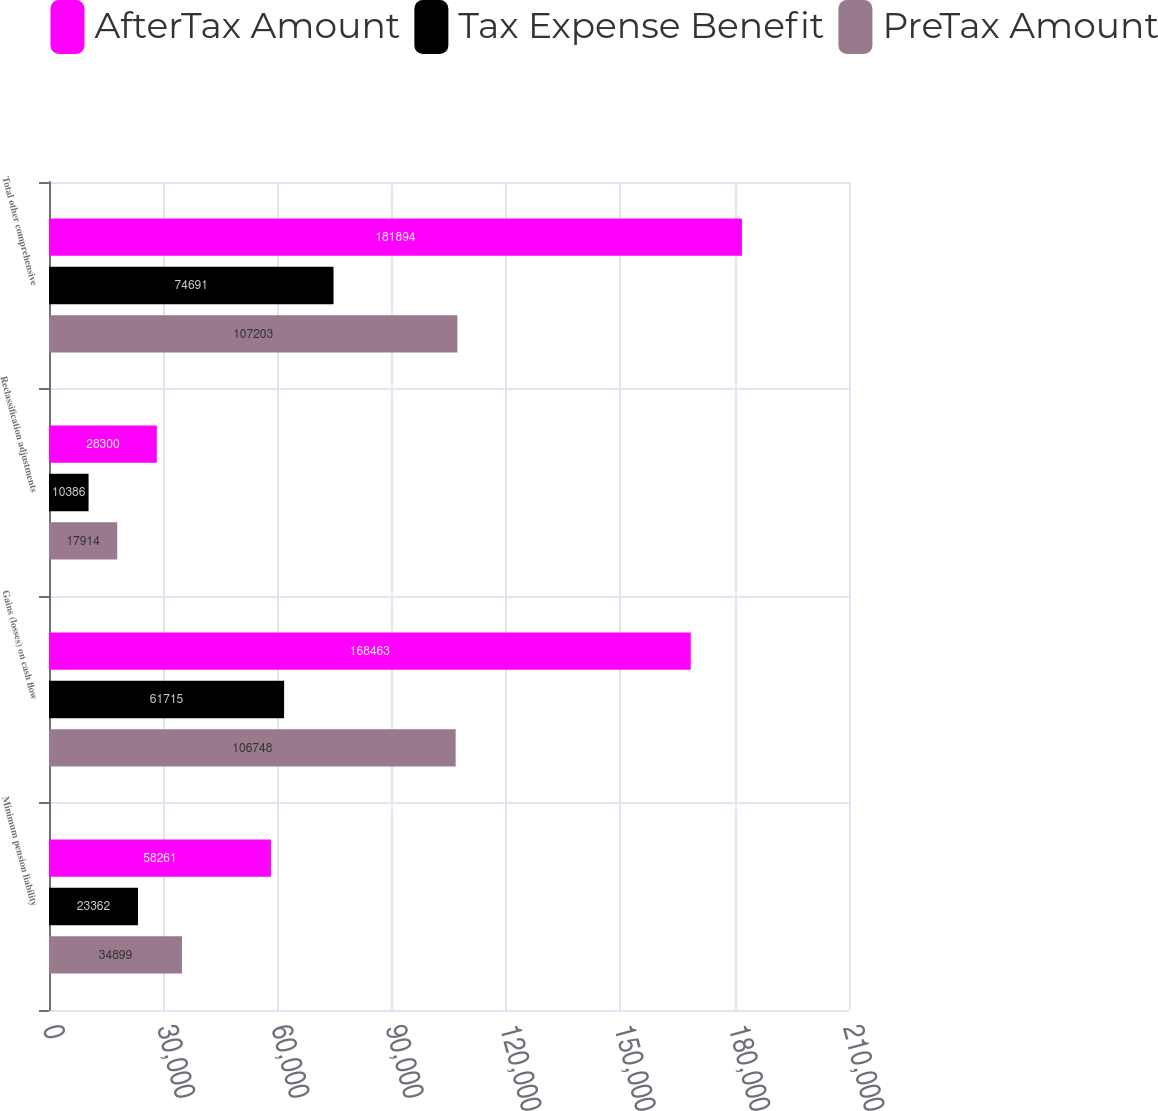Convert chart. <chart><loc_0><loc_0><loc_500><loc_500><stacked_bar_chart><ecel><fcel>Minimum pension liability<fcel>Gains (losses) on cash flow<fcel>Reclassification adjustments<fcel>Total other comprehensive<nl><fcel>AfterTax Amount<fcel>58261<fcel>168463<fcel>28300<fcel>181894<nl><fcel>Tax Expense Benefit<fcel>23362<fcel>61715<fcel>10386<fcel>74691<nl><fcel>PreTax Amount<fcel>34899<fcel>106748<fcel>17914<fcel>107203<nl></chart> 